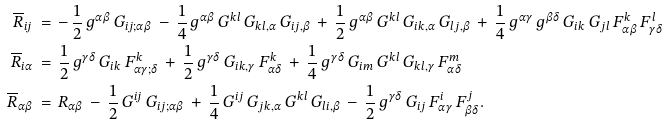Convert formula to latex. <formula><loc_0><loc_0><loc_500><loc_500>\overline { R } _ { i j } \, & = \, - \, \frac { 1 } { 2 } \, g ^ { \alpha \beta } \, G _ { i j ; \alpha \beta } \, - \, \frac { 1 } { 4 } \, g ^ { \alpha \beta } \, G ^ { k l } \, G _ { k l , \alpha } \, G _ { i j , \beta } \, + \, \frac { 1 } { 2 } \, g ^ { \alpha \beta } \, G ^ { k l } \, G _ { i k , \alpha } \, G _ { l j , \beta } \, + \, \frac { 1 } { 4 } \, g ^ { \alpha \gamma } \, g ^ { \beta \delta } \, G _ { i k } \, G _ { j l } \, F ^ { k } _ { \alpha \beta } \, F ^ { l } _ { \gamma \delta } \\ \overline { R } _ { i \alpha } \, & = \, \frac { 1 } { 2 } \, g ^ { \gamma \delta } \, G _ { i k } \, F ^ { k } _ { \alpha \gamma ; \delta } \, + \, \frac { 1 } { 2 } \, g ^ { \gamma \delta } \, G _ { i k , \gamma } \, F ^ { k } _ { \alpha \delta } \, + \, \frac { 1 } { 4 } \, g ^ { \gamma \delta } \, G _ { i m } \, G ^ { k l } \, G _ { k l , \gamma } \, F ^ { m } _ { \alpha \delta } \\ \overline { R } _ { \alpha \beta } \, & = \, R _ { \alpha \beta } \, - \, \frac { 1 } { 2 } \, G ^ { i j } \, G _ { i j ; \alpha \beta } \, + \, \frac { 1 } { 4 } \, G ^ { i j } \, G _ { j k , \alpha } \, G ^ { k l } \, G _ { l i , \beta } \, - \, \frac { 1 } { 2 } \, g ^ { \gamma \delta } \, G _ { i j } \, F ^ { i } _ { \alpha \gamma } \, F ^ { j } _ { \beta \delta } .</formula> 